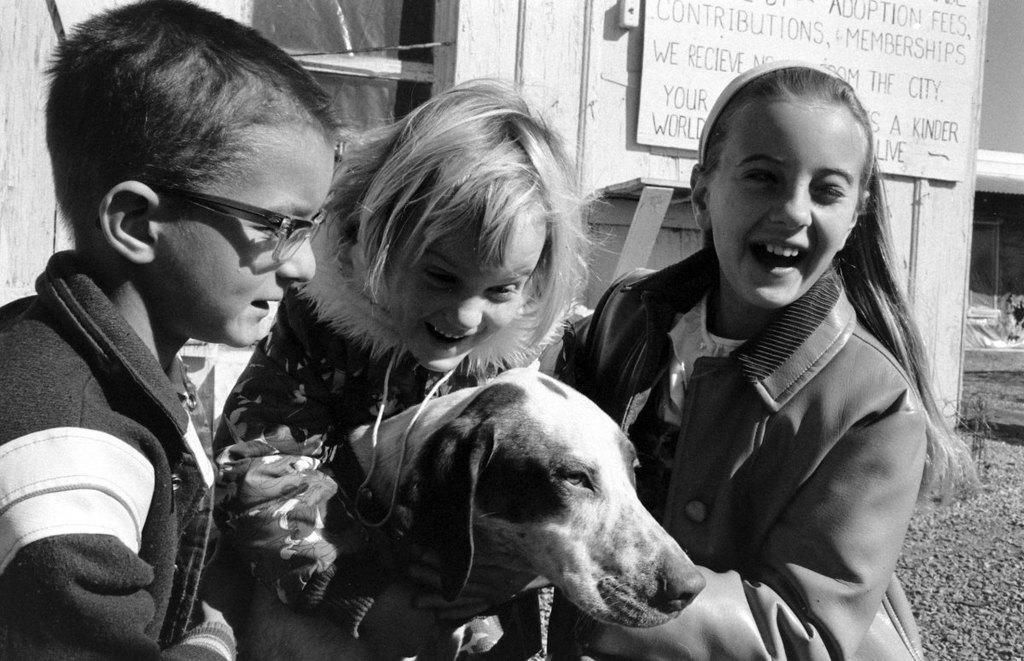How would you summarize this image in a sentence or two? This is a black and white image. There are two girls and one boy holding a dog. At background I can see a board which is attached to the wall. 